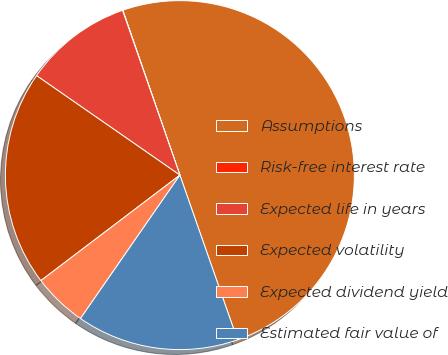Convert chart to OTSL. <chart><loc_0><loc_0><loc_500><loc_500><pie_chart><fcel>Assumptions<fcel>Risk-free interest rate<fcel>Expected life in years<fcel>Expected volatility<fcel>Expected dividend yield<fcel>Estimated fair value of<nl><fcel>49.95%<fcel>0.03%<fcel>10.01%<fcel>19.99%<fcel>5.02%<fcel>15.0%<nl></chart> 